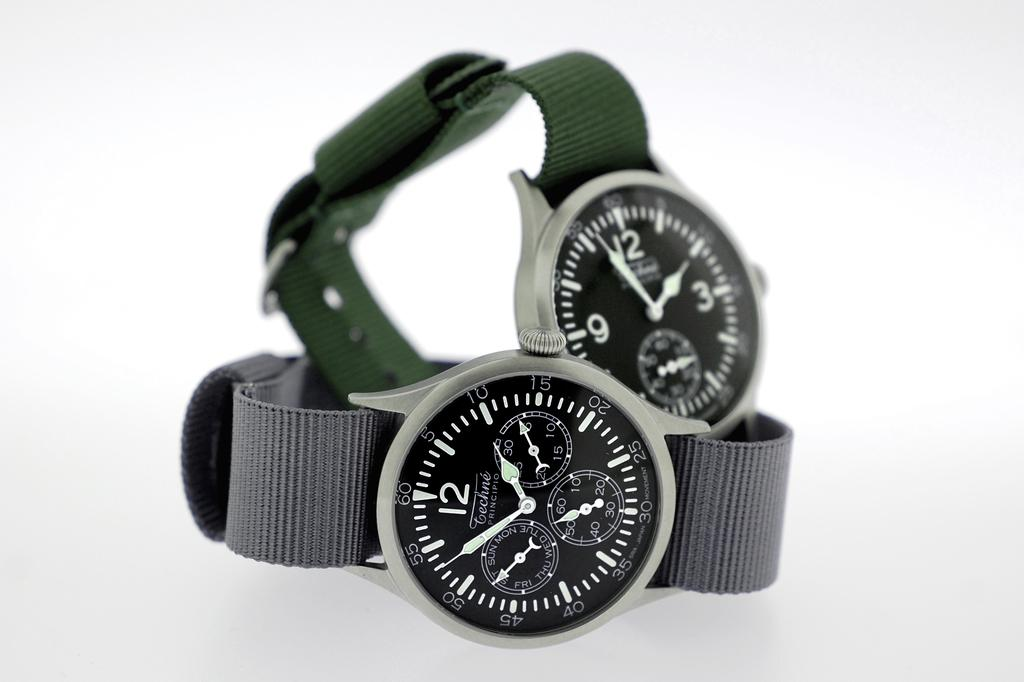<image>
Present a compact description of the photo's key features. A Tenchine brand watch is called the Principio. 